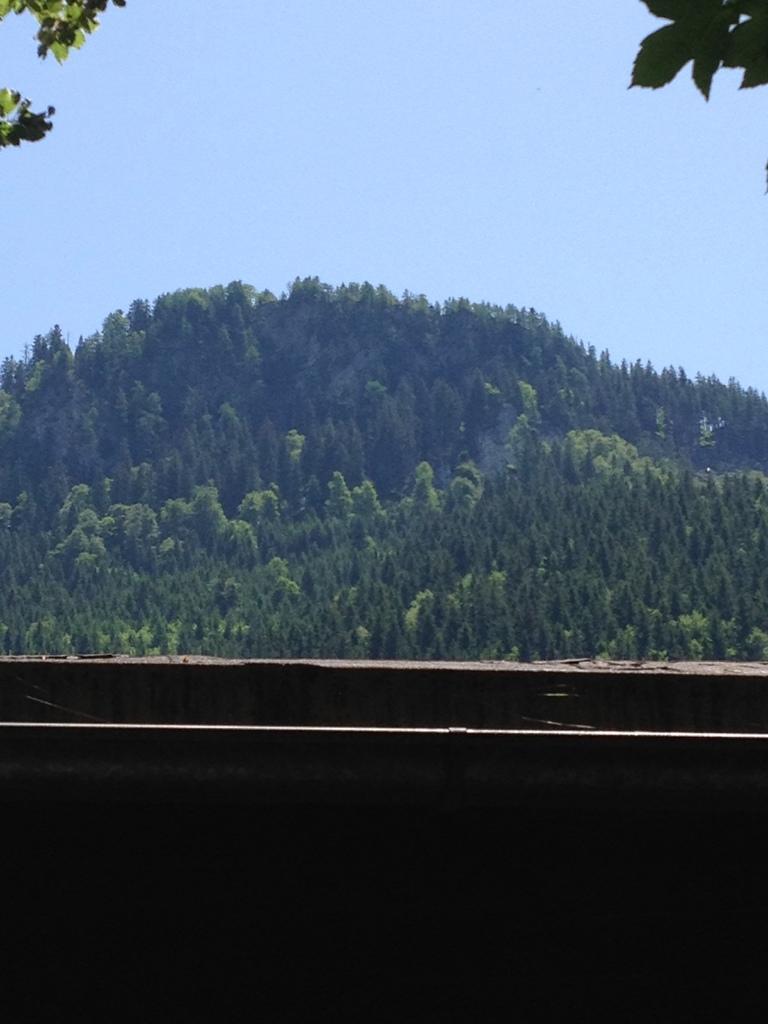In one or two sentences, can you explain what this image depicts? In this picture we can see few trees and a hill. 